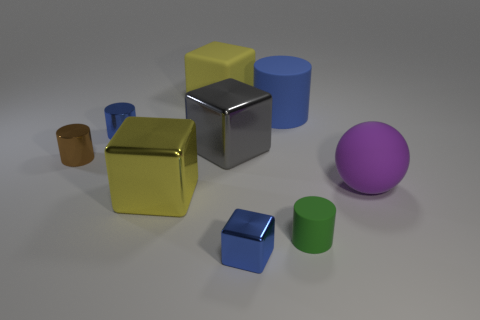Are there fewer small green things than tiny green balls?
Provide a short and direct response. No. What is the cylinder that is right of the big yellow shiny object and behind the purple ball made of?
Offer a very short reply. Rubber. Are there any small blue shiny blocks that are on the left side of the blue shiny object that is behind the large rubber ball?
Your response must be concise. No. How many things are either gray balls or tiny green matte things?
Your answer should be compact. 1. What shape is the blue object that is both to the right of the tiny blue cylinder and in front of the large blue rubber cylinder?
Give a very brief answer. Cube. Does the tiny cylinder to the right of the large gray object have the same material as the big gray thing?
Make the answer very short. No. How many objects are either metal things or large metallic cubes that are behind the yellow metallic block?
Give a very brief answer. 5. There is a sphere that is made of the same material as the big cylinder; what color is it?
Your answer should be very brief. Purple. How many small cylinders are made of the same material as the large gray cube?
Provide a succinct answer. 2. What number of large purple rubber things are there?
Make the answer very short. 1. 